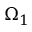Convert formula to latex. <formula><loc_0><loc_0><loc_500><loc_500>\Omega _ { 1 }</formula> 